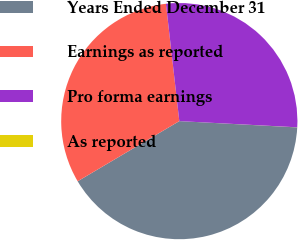Convert chart. <chart><loc_0><loc_0><loc_500><loc_500><pie_chart><fcel>Years Ended December 31<fcel>Earnings as reported<fcel>Pro forma earnings<fcel>As reported<nl><fcel>40.64%<fcel>31.7%<fcel>27.64%<fcel>0.01%<nl></chart> 